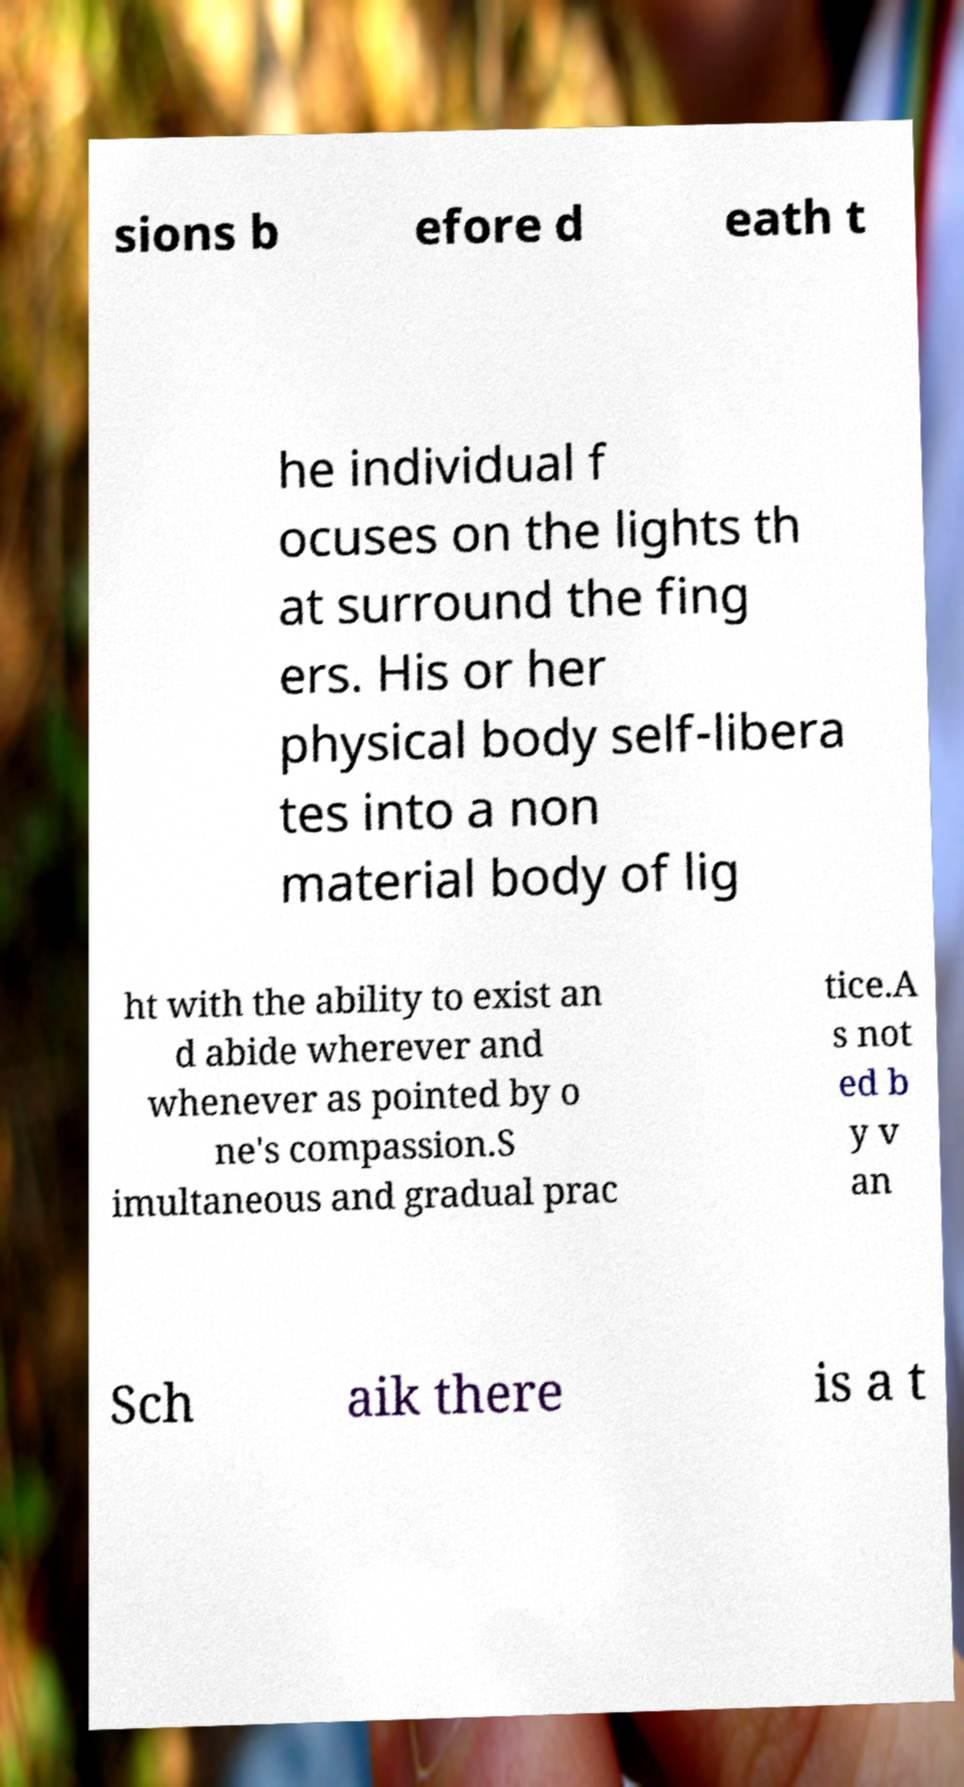Can you read and provide the text displayed in the image?This photo seems to have some interesting text. Can you extract and type it out for me? sions b efore d eath t he individual f ocuses on the lights th at surround the fing ers. His or her physical body self-libera tes into a non material body of lig ht with the ability to exist an d abide wherever and whenever as pointed by o ne's compassion.S imultaneous and gradual prac tice.A s not ed b y v an Sch aik there is a t 